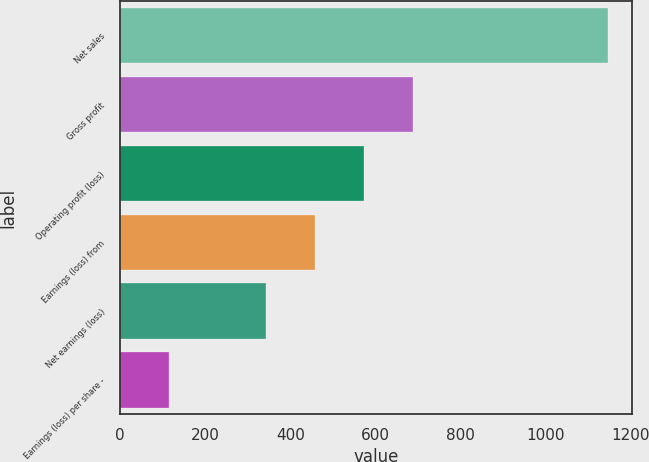Convert chart. <chart><loc_0><loc_0><loc_500><loc_500><bar_chart><fcel>Net sales<fcel>Gross profit<fcel>Operating profit (loss)<fcel>Earnings (loss) from<fcel>Net earnings (loss)<fcel>Earnings (loss) per share -<nl><fcel>1146<fcel>687.64<fcel>573.06<fcel>458.48<fcel>343.9<fcel>114.74<nl></chart> 